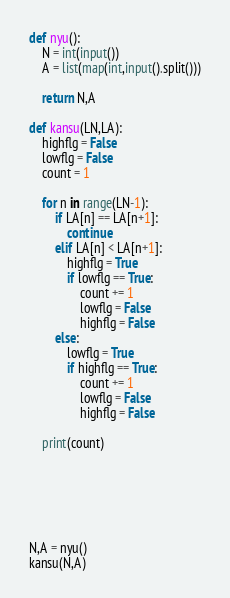Convert code to text. <code><loc_0><loc_0><loc_500><loc_500><_Python_>def nyu():
    N = int(input())
    A = list(map(int,input().split()))

    return N,A

def kansu(LN,LA):
    highflg = False
    lowflg = False
    count = 1

    for n in range(LN-1):
        if LA[n] == LA[n+1]:
            continue
        elif LA[n] < LA[n+1]:
            highflg = True
            if lowflg == True:
                count += 1
                lowflg = False
                highflg = False
        else:
            lowflg = True
            if highflg == True:
                count += 1
                lowflg = False
                highflg = False
    
    print(count)






N,A = nyu()
kansu(N,A)</code> 